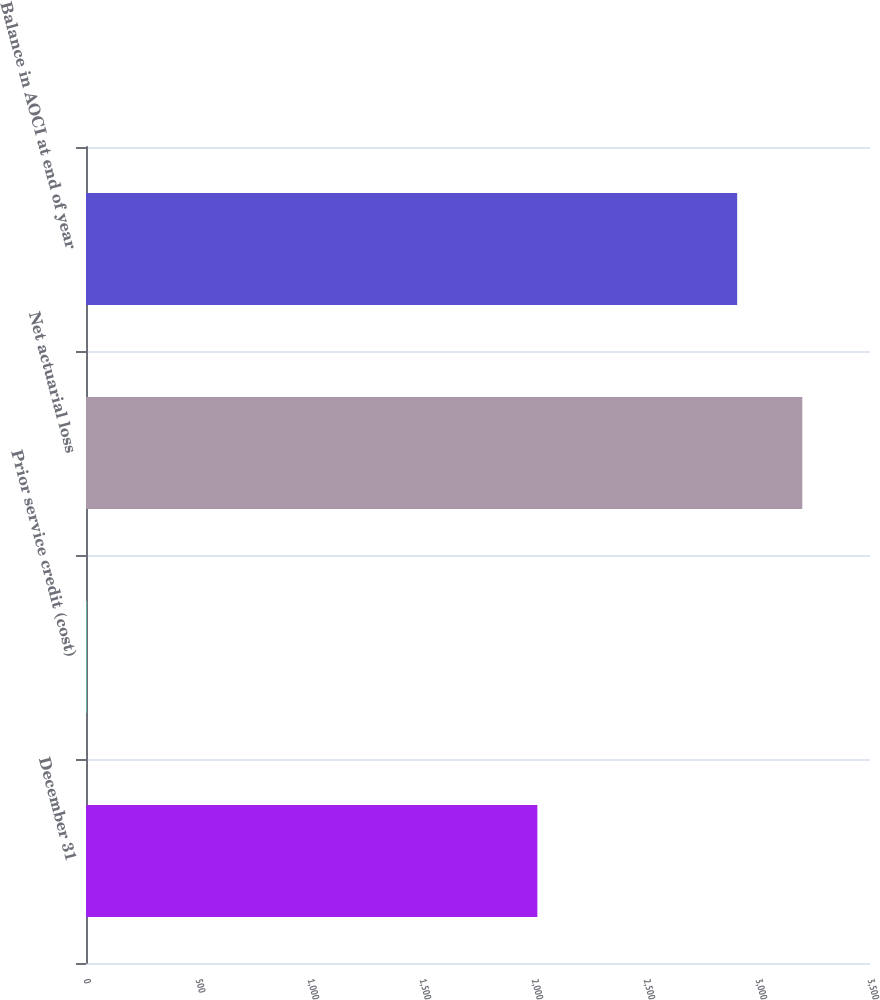<chart> <loc_0><loc_0><loc_500><loc_500><bar_chart><fcel>December 31<fcel>Prior service credit (cost)<fcel>Net actuarial loss<fcel>Balance in AOCI at end of year<nl><fcel>2015<fcel>3<fcel>3197.7<fcel>2907<nl></chart> 